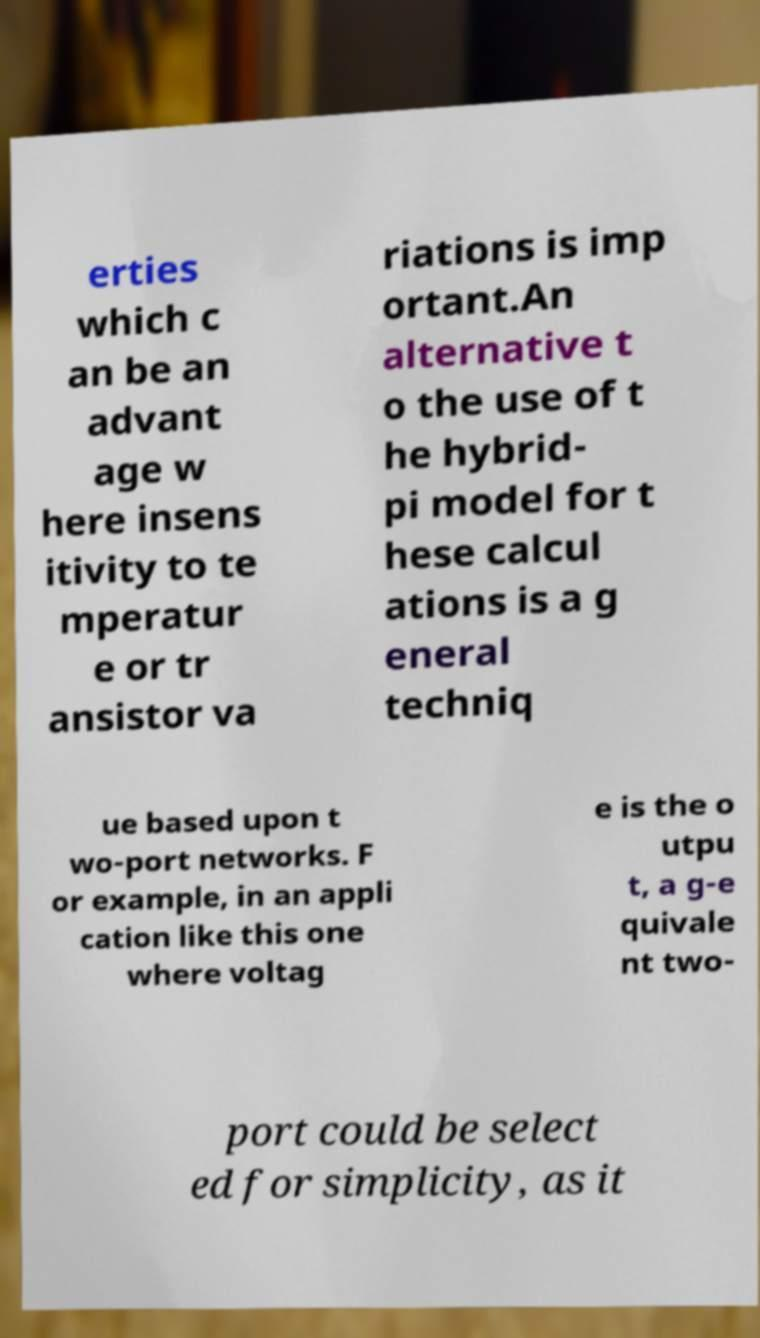Could you extract and type out the text from this image? erties which c an be an advant age w here insens itivity to te mperatur e or tr ansistor va riations is imp ortant.An alternative t o the use of t he hybrid- pi model for t hese calcul ations is a g eneral techniq ue based upon t wo-port networks. F or example, in an appli cation like this one where voltag e is the o utpu t, a g-e quivale nt two- port could be select ed for simplicity, as it 